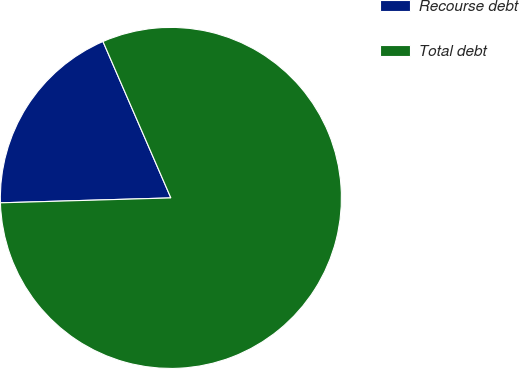<chart> <loc_0><loc_0><loc_500><loc_500><pie_chart><fcel>Recourse debt<fcel>Total debt<nl><fcel>18.94%<fcel>81.06%<nl></chart> 